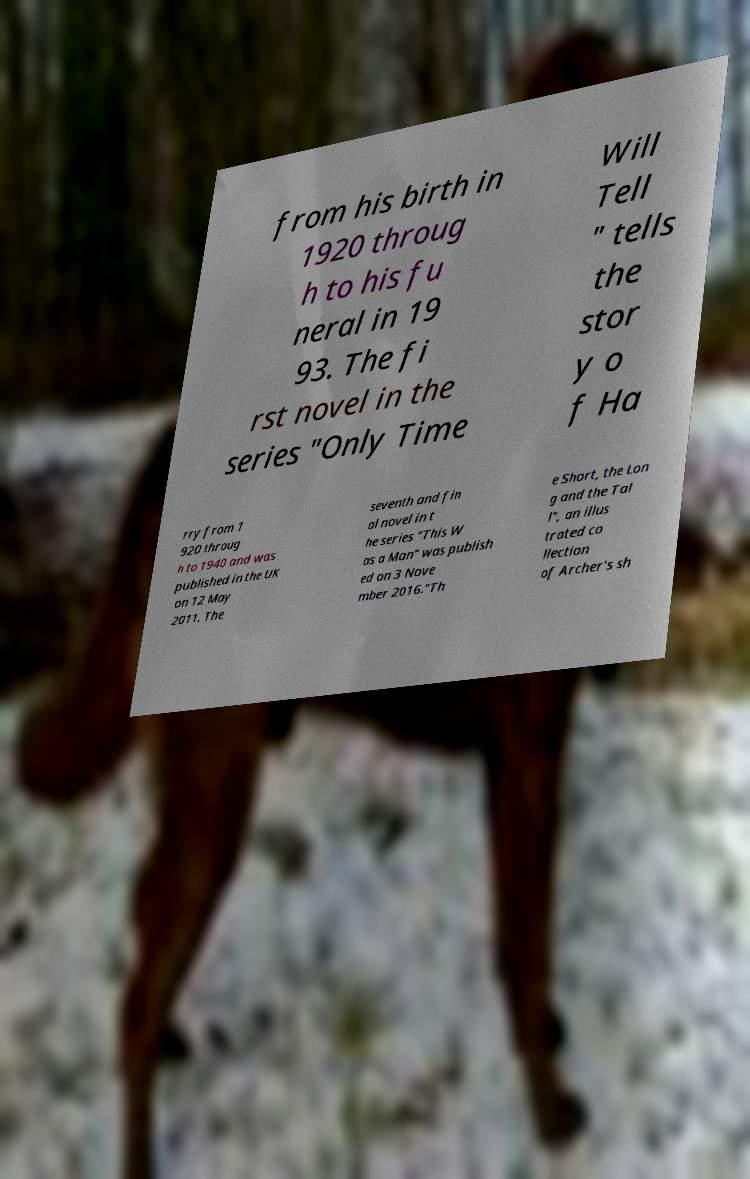Please identify and transcribe the text found in this image. from his birth in 1920 throug h to his fu neral in 19 93. The fi rst novel in the series "Only Time Will Tell " tells the stor y o f Ha rry from 1 920 throug h to 1940 and was published in the UK on 12 May 2011. The seventh and fin al novel in t he series "This W as a Man" was publish ed on 3 Nove mber 2016."Th e Short, the Lon g and the Tal l", an illus trated co llection of Archer's sh 